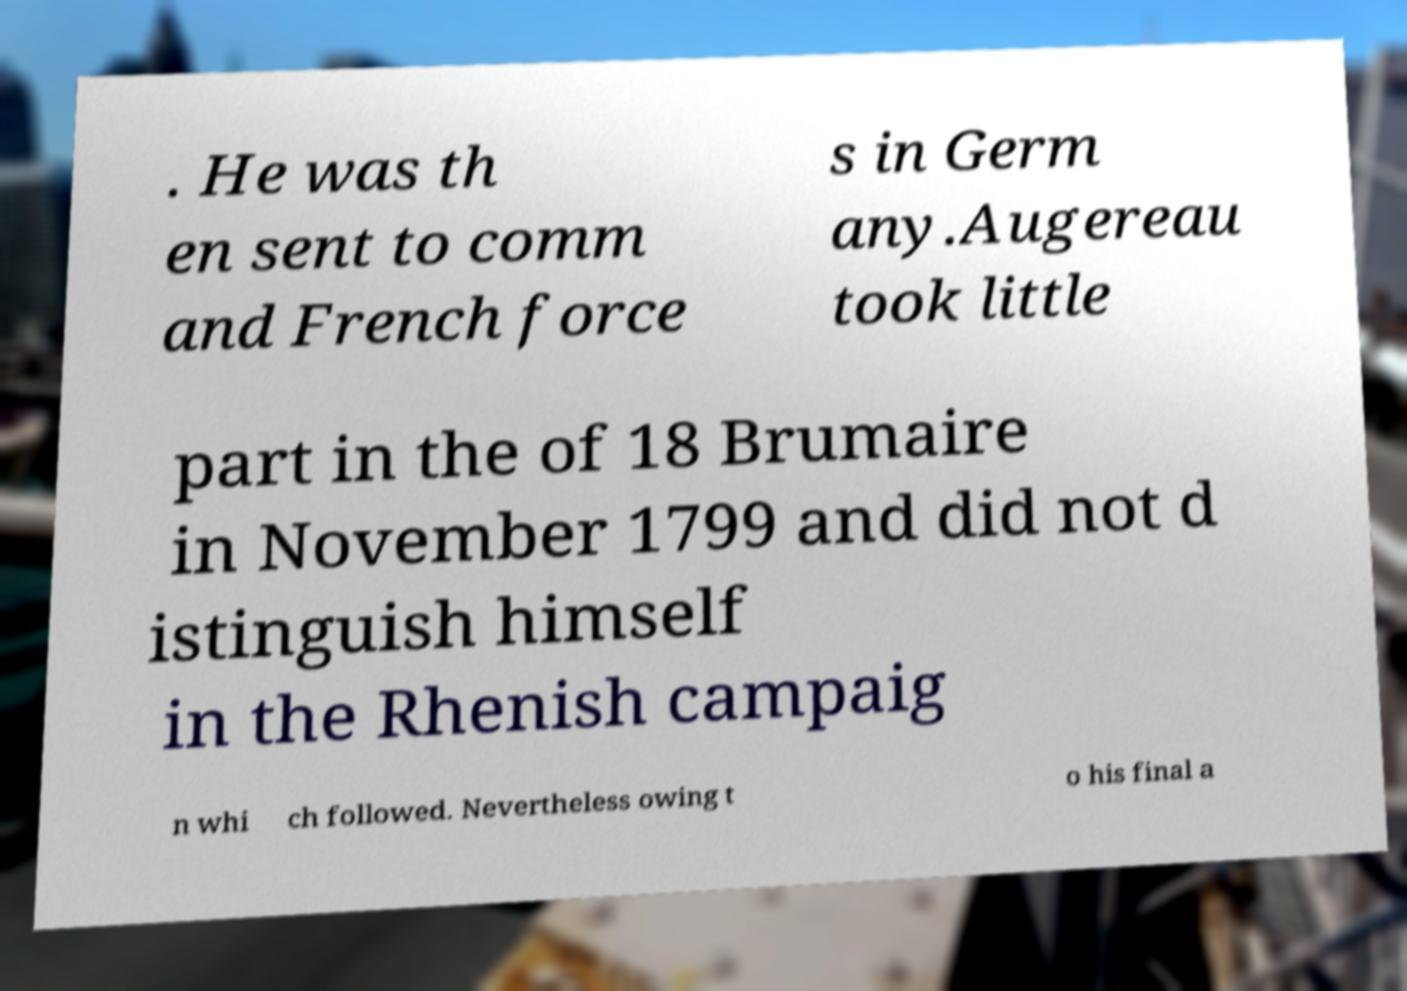Please read and relay the text visible in this image. What does it say? . He was th en sent to comm and French force s in Germ any.Augereau took little part in the of 18 Brumaire in November 1799 and did not d istinguish himself in the Rhenish campaig n whi ch followed. Nevertheless owing t o his final a 